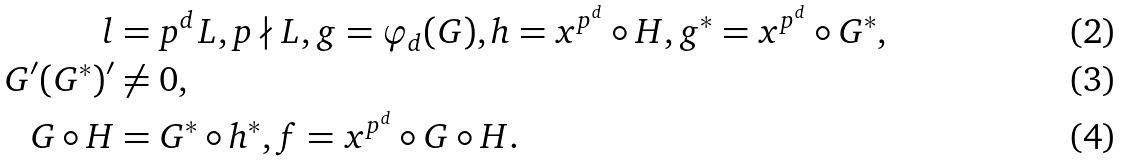Convert formula to latex. <formula><loc_0><loc_0><loc_500><loc_500>l & = p ^ { d } L , p \nmid L , g = \varphi _ { d } ( G ) , h = x ^ { p ^ { d } } \circ H , g ^ { * } = x ^ { p ^ { d } } \circ G ^ { * } , \\ G ^ { \prime } ( G ^ { * } ) ^ { \prime } & \neq 0 , \\ G \circ H & = G ^ { * } \circ h ^ { * } , f = x ^ { p ^ { d } } \circ G \circ H .</formula> 